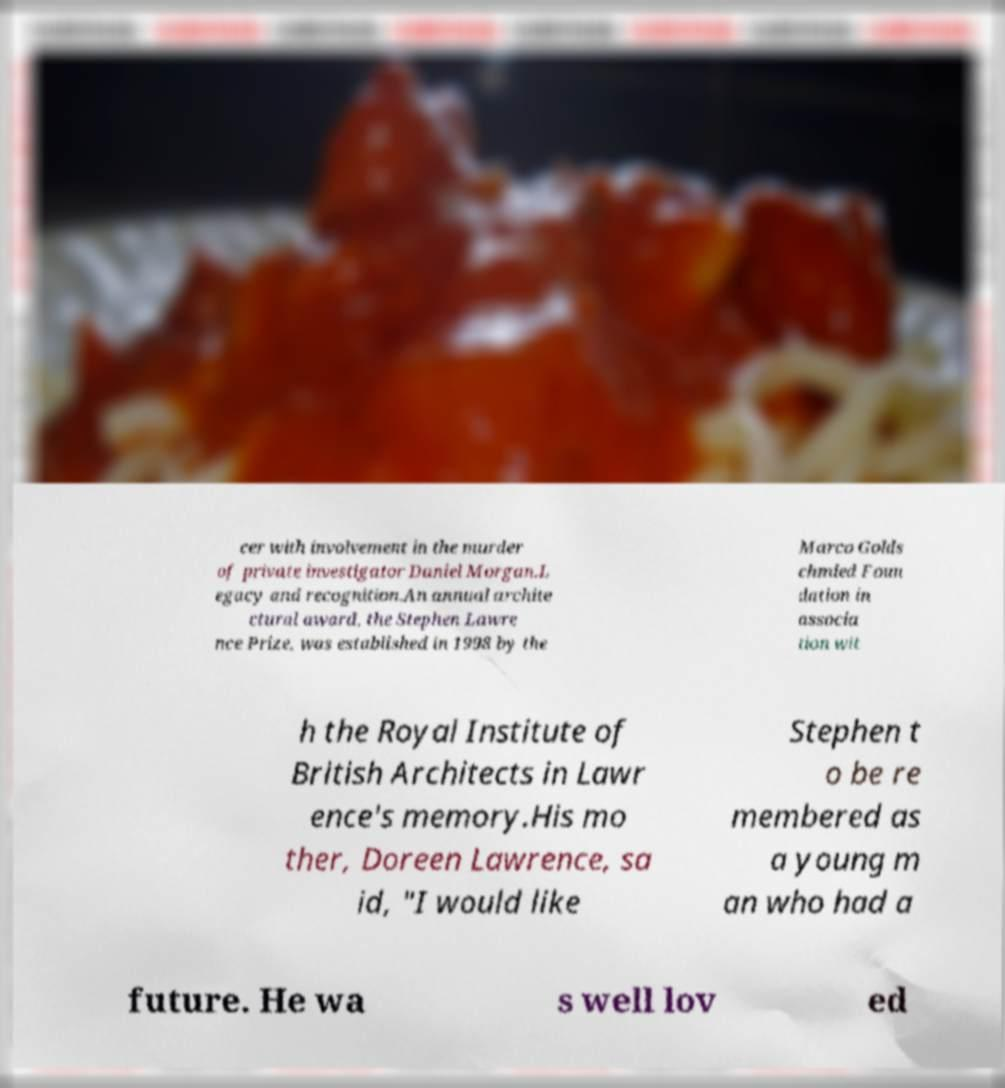I need the written content from this picture converted into text. Can you do that? cer with involvement in the murder of private investigator Daniel Morgan.L egacy and recognition.An annual archite ctural award, the Stephen Lawre nce Prize, was established in 1998 by the Marco Golds chmied Foun dation in associa tion wit h the Royal Institute of British Architects in Lawr ence's memory.His mo ther, Doreen Lawrence, sa id, "I would like Stephen t o be re membered as a young m an who had a future. He wa s well lov ed 